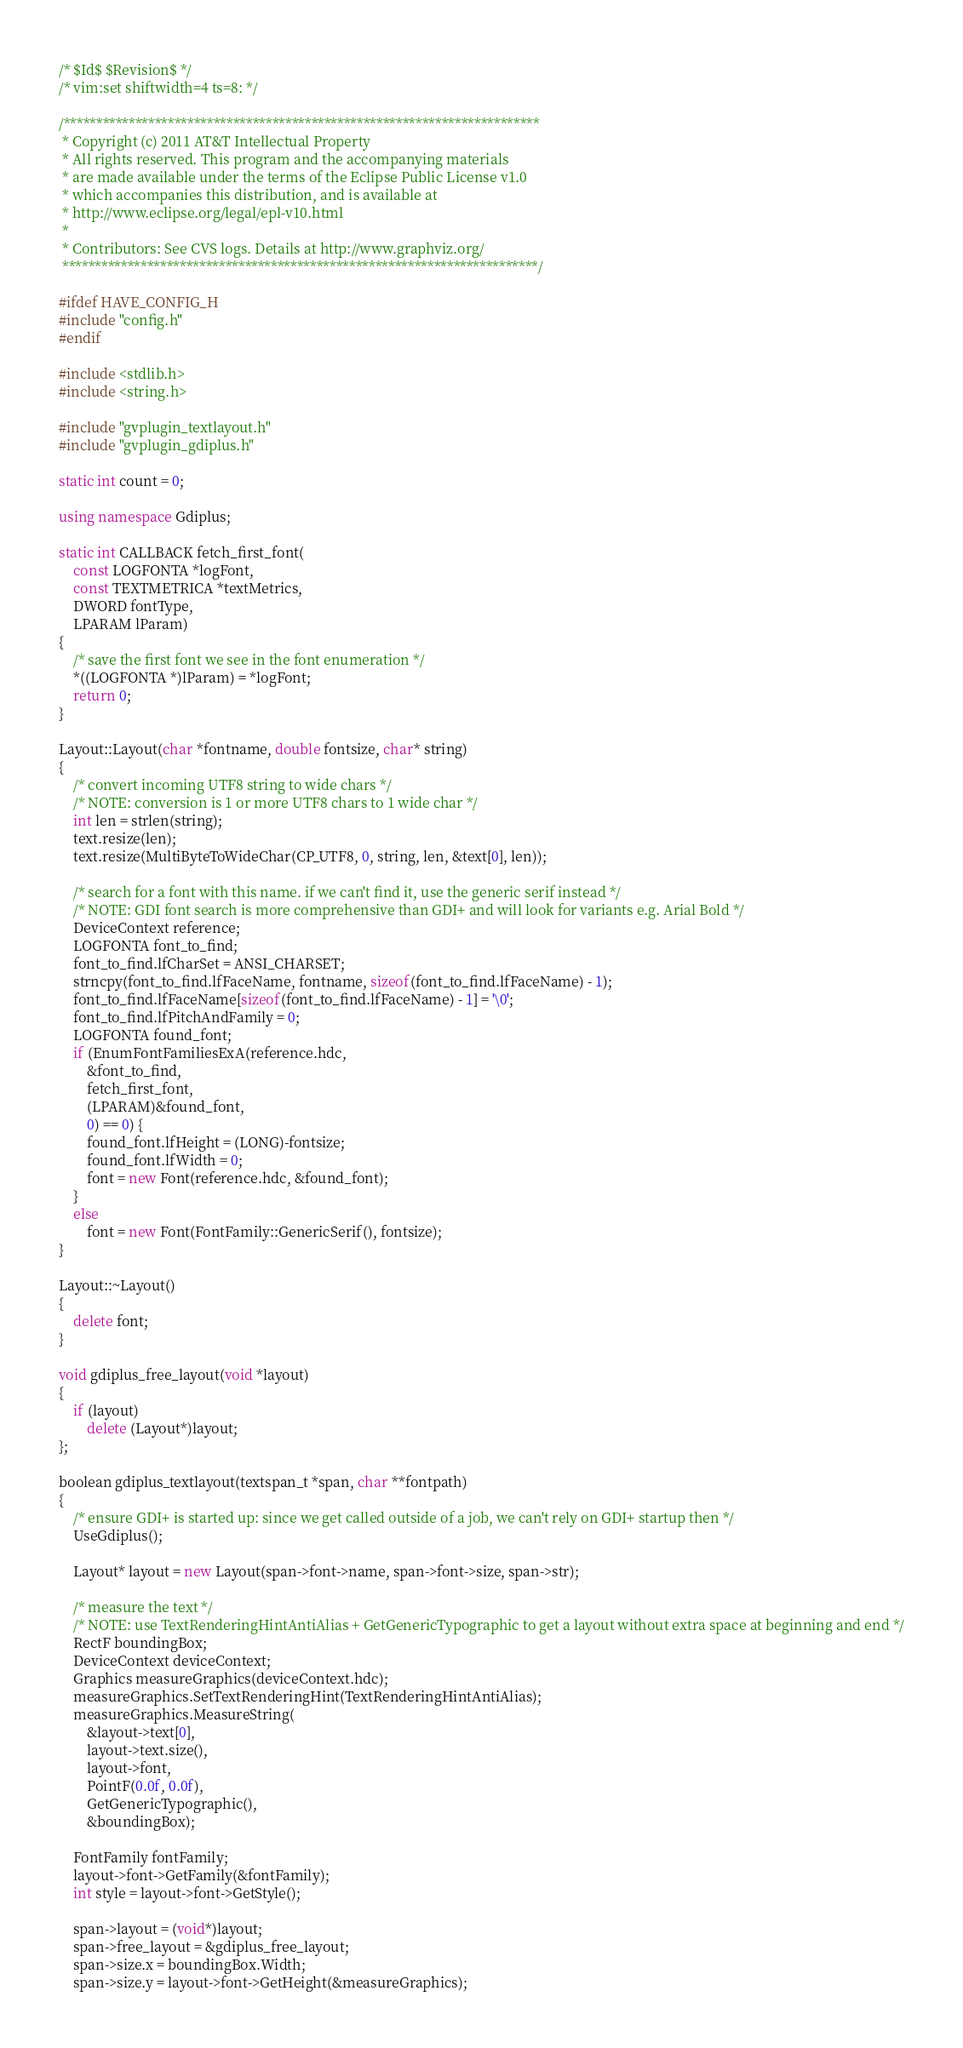<code> <loc_0><loc_0><loc_500><loc_500><_C++_>/* $Id$ $Revision$ */
/* vim:set shiftwidth=4 ts=8: */

/*************************************************************************
 * Copyright (c) 2011 AT&T Intellectual Property 
 * All rights reserved. This program and the accompanying materials
 * are made available under the terms of the Eclipse Public License v1.0
 * which accompanies this distribution, and is available at
 * http://www.eclipse.org/legal/epl-v10.html
 *
 * Contributors: See CVS logs. Details at http://www.graphviz.org/
 *************************************************************************/

#ifdef HAVE_CONFIG_H
#include "config.h"
#endif

#include <stdlib.h>
#include <string.h>

#include "gvplugin_textlayout.h"
#include "gvplugin_gdiplus.h"

static int count = 0;

using namespace Gdiplus;

static int CALLBACK fetch_first_font(
	const LOGFONTA *logFont,
	const TEXTMETRICA *textMetrics,
	DWORD fontType,
	LPARAM lParam)
{
	/* save the first font we see in the font enumeration */
	*((LOGFONTA *)lParam) = *logFont;
	return 0;
}

Layout::Layout(char *fontname, double fontsize, char* string)
{
	/* convert incoming UTF8 string to wide chars */
	/* NOTE: conversion is 1 or more UTF8 chars to 1 wide char */
	int len = strlen(string);
	text.resize(len);
	text.resize(MultiByteToWideChar(CP_UTF8, 0, string, len, &text[0], len));

	/* search for a font with this name. if we can't find it, use the generic serif instead */
	/* NOTE: GDI font search is more comprehensive than GDI+ and will look for variants e.g. Arial Bold */
	DeviceContext reference;
	LOGFONTA font_to_find;
	font_to_find.lfCharSet = ANSI_CHARSET;
	strncpy(font_to_find.lfFaceName, fontname, sizeof(font_to_find.lfFaceName) - 1);
	font_to_find.lfFaceName[sizeof(font_to_find.lfFaceName) - 1] = '\0';
	font_to_find.lfPitchAndFamily = 0;
	LOGFONTA found_font;
	if (EnumFontFamiliesExA(reference.hdc,
		&font_to_find,
		fetch_first_font,
		(LPARAM)&found_font,
		0) == 0) {
		found_font.lfHeight = (LONG)-fontsize;
		found_font.lfWidth = 0;
		font = new Font(reference.hdc, &found_font);
	}
	else
		font = new Font(FontFamily::GenericSerif(), fontsize);
}

Layout::~Layout()
{
	delete font;
}

void gdiplus_free_layout(void *layout)
{
	if (layout)
		delete (Layout*)layout;
};

boolean gdiplus_textlayout(textspan_t *span, char **fontpath)
{
	/* ensure GDI+ is started up: since we get called outside of a job, we can't rely on GDI+ startup then */
	UseGdiplus();
	
	Layout* layout = new Layout(span->font->name, span->font->size, span->str);
	
	/* measure the text */
	/* NOTE: use TextRenderingHintAntiAlias + GetGenericTypographic to get a layout without extra space at beginning and end */
	RectF boundingBox;
	DeviceContext deviceContext;
	Graphics measureGraphics(deviceContext.hdc);
	measureGraphics.SetTextRenderingHint(TextRenderingHintAntiAlias);
	measureGraphics.MeasureString(
		&layout->text[0],
		layout->text.size(),
		layout->font,
		PointF(0.0f, 0.0f),
		GetGenericTypographic(),
		&boundingBox);
		
	FontFamily fontFamily;
	layout->font->GetFamily(&fontFamily);
	int style = layout->font->GetStyle();
		
	span->layout = (void*)layout;
	span->free_layout = &gdiplus_free_layout;
	span->size.x = boundingBox.Width;
	span->size.y = layout->font->GetHeight(&measureGraphics);</code> 